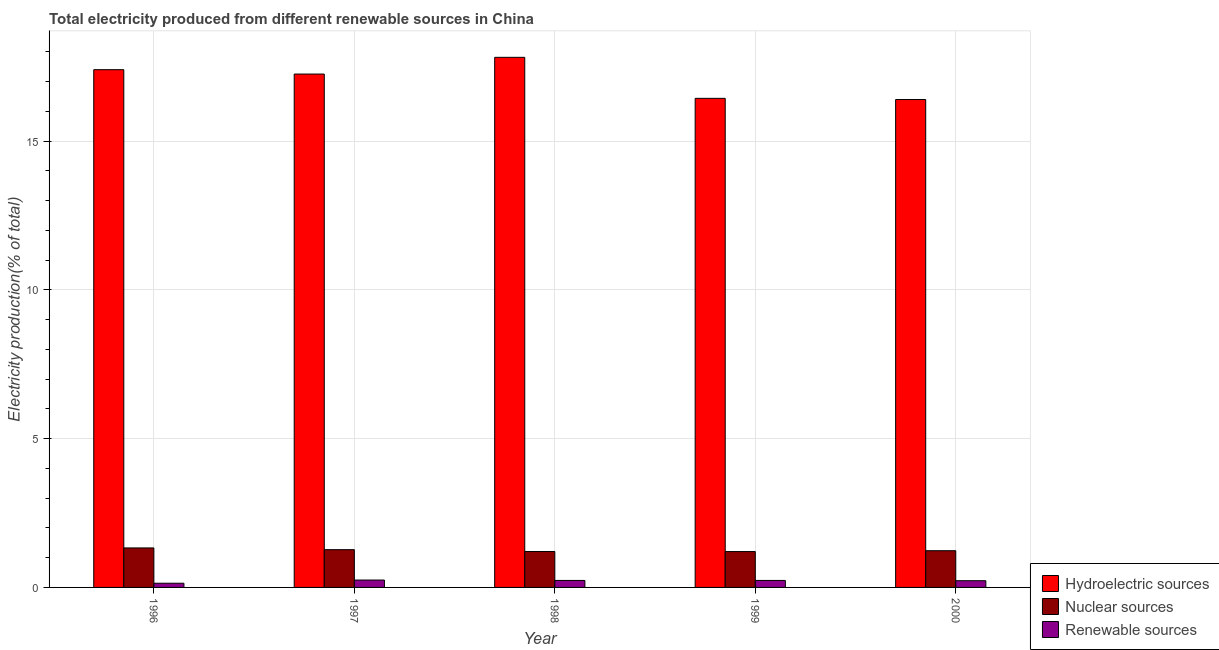How many different coloured bars are there?
Keep it short and to the point. 3. How many groups of bars are there?
Give a very brief answer. 5. How many bars are there on the 2nd tick from the right?
Provide a short and direct response. 3. What is the label of the 5th group of bars from the left?
Your response must be concise. 2000. What is the percentage of electricity produced by nuclear sources in 2000?
Give a very brief answer. 1.23. Across all years, what is the maximum percentage of electricity produced by nuclear sources?
Provide a succinct answer. 1.33. Across all years, what is the minimum percentage of electricity produced by nuclear sources?
Your response must be concise. 1.21. In which year was the percentage of electricity produced by renewable sources maximum?
Provide a succinct answer. 1997. What is the total percentage of electricity produced by renewable sources in the graph?
Your answer should be compact. 1.09. What is the difference between the percentage of electricity produced by hydroelectric sources in 1996 and that in 2000?
Provide a short and direct response. 1. What is the difference between the percentage of electricity produced by nuclear sources in 1999 and the percentage of electricity produced by renewable sources in 1997?
Provide a short and direct response. -0.06. What is the average percentage of electricity produced by hydroelectric sources per year?
Offer a very short reply. 17.06. In the year 1999, what is the difference between the percentage of electricity produced by nuclear sources and percentage of electricity produced by renewable sources?
Offer a terse response. 0. In how many years, is the percentage of electricity produced by nuclear sources greater than 15 %?
Make the answer very short. 0. What is the ratio of the percentage of electricity produced by renewable sources in 1996 to that in 2000?
Provide a short and direct response. 0.63. What is the difference between the highest and the second highest percentage of electricity produced by hydroelectric sources?
Provide a short and direct response. 0.42. What is the difference between the highest and the lowest percentage of electricity produced by renewable sources?
Give a very brief answer. 0.11. Is the sum of the percentage of electricity produced by nuclear sources in 1997 and 2000 greater than the maximum percentage of electricity produced by renewable sources across all years?
Make the answer very short. Yes. What does the 3rd bar from the left in 1996 represents?
Provide a succinct answer. Renewable sources. What does the 2nd bar from the right in 1999 represents?
Make the answer very short. Nuclear sources. Are all the bars in the graph horizontal?
Give a very brief answer. No. How many years are there in the graph?
Your answer should be compact. 5. What is the difference between two consecutive major ticks on the Y-axis?
Offer a very short reply. 5. How many legend labels are there?
Ensure brevity in your answer.  3. How are the legend labels stacked?
Offer a terse response. Vertical. What is the title of the graph?
Your response must be concise. Total electricity produced from different renewable sources in China. What is the Electricity production(% of total) of Hydroelectric sources in 1996?
Make the answer very short. 17.4. What is the Electricity production(% of total) of Nuclear sources in 1996?
Provide a short and direct response. 1.33. What is the Electricity production(% of total) of Renewable sources in 1996?
Provide a succinct answer. 0.14. What is the Electricity production(% of total) in Hydroelectric sources in 1997?
Make the answer very short. 17.26. What is the Electricity production(% of total) of Nuclear sources in 1997?
Offer a very short reply. 1.27. What is the Electricity production(% of total) in Renewable sources in 1997?
Your response must be concise. 0.25. What is the Electricity production(% of total) of Hydroelectric sources in 1998?
Your answer should be very brief. 17.82. What is the Electricity production(% of total) of Nuclear sources in 1998?
Make the answer very short. 1.21. What is the Electricity production(% of total) in Renewable sources in 1998?
Offer a terse response. 0.24. What is the Electricity production(% of total) of Hydroelectric sources in 1999?
Give a very brief answer. 16.44. What is the Electricity production(% of total) of Nuclear sources in 1999?
Make the answer very short. 1.21. What is the Electricity production(% of total) of Renewable sources in 1999?
Your answer should be very brief. 0.24. What is the Electricity production(% of total) in Hydroelectric sources in 2000?
Your response must be concise. 16.4. What is the Electricity production(% of total) in Nuclear sources in 2000?
Offer a terse response. 1.23. What is the Electricity production(% of total) in Renewable sources in 2000?
Your answer should be very brief. 0.23. Across all years, what is the maximum Electricity production(% of total) of Hydroelectric sources?
Provide a short and direct response. 17.82. Across all years, what is the maximum Electricity production(% of total) in Nuclear sources?
Provide a short and direct response. 1.33. Across all years, what is the maximum Electricity production(% of total) of Renewable sources?
Keep it short and to the point. 0.25. Across all years, what is the minimum Electricity production(% of total) of Hydroelectric sources?
Ensure brevity in your answer.  16.4. Across all years, what is the minimum Electricity production(% of total) in Nuclear sources?
Provide a short and direct response. 1.21. Across all years, what is the minimum Electricity production(% of total) in Renewable sources?
Your response must be concise. 0.14. What is the total Electricity production(% of total) in Hydroelectric sources in the graph?
Keep it short and to the point. 85.31. What is the total Electricity production(% of total) in Nuclear sources in the graph?
Provide a short and direct response. 6.24. What is the total Electricity production(% of total) in Renewable sources in the graph?
Your response must be concise. 1.09. What is the difference between the Electricity production(% of total) of Hydroelectric sources in 1996 and that in 1997?
Give a very brief answer. 0.15. What is the difference between the Electricity production(% of total) of Nuclear sources in 1996 and that in 1997?
Offer a very short reply. 0.06. What is the difference between the Electricity production(% of total) of Renewable sources in 1996 and that in 1997?
Provide a succinct answer. -0.11. What is the difference between the Electricity production(% of total) of Hydroelectric sources in 1996 and that in 1998?
Keep it short and to the point. -0.42. What is the difference between the Electricity production(% of total) of Nuclear sources in 1996 and that in 1998?
Provide a short and direct response. 0.12. What is the difference between the Electricity production(% of total) of Renewable sources in 1996 and that in 1998?
Give a very brief answer. -0.09. What is the difference between the Electricity production(% of total) of Hydroelectric sources in 1996 and that in 1999?
Offer a terse response. 0.96. What is the difference between the Electricity production(% of total) of Nuclear sources in 1996 and that in 1999?
Your answer should be compact. 0.12. What is the difference between the Electricity production(% of total) in Renewable sources in 1996 and that in 1999?
Give a very brief answer. -0.09. What is the difference between the Electricity production(% of total) of Hydroelectric sources in 1996 and that in 2000?
Your response must be concise. 1. What is the difference between the Electricity production(% of total) of Nuclear sources in 1996 and that in 2000?
Give a very brief answer. 0.09. What is the difference between the Electricity production(% of total) of Renewable sources in 1996 and that in 2000?
Your answer should be very brief. -0.08. What is the difference between the Electricity production(% of total) of Hydroelectric sources in 1997 and that in 1998?
Your answer should be compact. -0.56. What is the difference between the Electricity production(% of total) in Nuclear sources in 1997 and that in 1998?
Offer a very short reply. 0.06. What is the difference between the Electricity production(% of total) in Renewable sources in 1997 and that in 1998?
Offer a very short reply. 0.01. What is the difference between the Electricity production(% of total) in Hydroelectric sources in 1997 and that in 1999?
Make the answer very short. 0.82. What is the difference between the Electricity production(% of total) of Nuclear sources in 1997 and that in 1999?
Give a very brief answer. 0.06. What is the difference between the Electricity production(% of total) in Renewable sources in 1997 and that in 1999?
Give a very brief answer. 0.01. What is the difference between the Electricity production(% of total) in Hydroelectric sources in 1997 and that in 2000?
Keep it short and to the point. 0.86. What is the difference between the Electricity production(% of total) in Nuclear sources in 1997 and that in 2000?
Keep it short and to the point. 0.04. What is the difference between the Electricity production(% of total) of Renewable sources in 1997 and that in 2000?
Make the answer very short. 0.02. What is the difference between the Electricity production(% of total) in Hydroelectric sources in 1998 and that in 1999?
Offer a very short reply. 1.38. What is the difference between the Electricity production(% of total) of Nuclear sources in 1998 and that in 1999?
Your answer should be compact. 0. What is the difference between the Electricity production(% of total) in Renewable sources in 1998 and that in 1999?
Make the answer very short. 0. What is the difference between the Electricity production(% of total) of Hydroelectric sources in 1998 and that in 2000?
Give a very brief answer. 1.42. What is the difference between the Electricity production(% of total) in Nuclear sources in 1998 and that in 2000?
Make the answer very short. -0.03. What is the difference between the Electricity production(% of total) of Renewable sources in 1998 and that in 2000?
Make the answer very short. 0.01. What is the difference between the Electricity production(% of total) of Hydroelectric sources in 1999 and that in 2000?
Provide a short and direct response. 0.04. What is the difference between the Electricity production(% of total) in Nuclear sources in 1999 and that in 2000?
Your response must be concise. -0.03. What is the difference between the Electricity production(% of total) in Renewable sources in 1999 and that in 2000?
Ensure brevity in your answer.  0.01. What is the difference between the Electricity production(% of total) in Hydroelectric sources in 1996 and the Electricity production(% of total) in Nuclear sources in 1997?
Your answer should be compact. 16.13. What is the difference between the Electricity production(% of total) of Hydroelectric sources in 1996 and the Electricity production(% of total) of Renewable sources in 1997?
Make the answer very short. 17.15. What is the difference between the Electricity production(% of total) of Nuclear sources in 1996 and the Electricity production(% of total) of Renewable sources in 1997?
Provide a short and direct response. 1.08. What is the difference between the Electricity production(% of total) in Hydroelectric sources in 1996 and the Electricity production(% of total) in Nuclear sources in 1998?
Provide a short and direct response. 16.19. What is the difference between the Electricity production(% of total) of Hydroelectric sources in 1996 and the Electricity production(% of total) of Renewable sources in 1998?
Keep it short and to the point. 17.17. What is the difference between the Electricity production(% of total) in Nuclear sources in 1996 and the Electricity production(% of total) in Renewable sources in 1998?
Offer a terse response. 1.09. What is the difference between the Electricity production(% of total) in Hydroelectric sources in 1996 and the Electricity production(% of total) in Nuclear sources in 1999?
Your answer should be compact. 16.2. What is the difference between the Electricity production(% of total) of Hydroelectric sources in 1996 and the Electricity production(% of total) of Renewable sources in 1999?
Ensure brevity in your answer.  17.17. What is the difference between the Electricity production(% of total) of Nuclear sources in 1996 and the Electricity production(% of total) of Renewable sources in 1999?
Your answer should be very brief. 1.09. What is the difference between the Electricity production(% of total) of Hydroelectric sources in 1996 and the Electricity production(% of total) of Nuclear sources in 2000?
Provide a short and direct response. 16.17. What is the difference between the Electricity production(% of total) in Hydroelectric sources in 1996 and the Electricity production(% of total) in Renewable sources in 2000?
Give a very brief answer. 17.18. What is the difference between the Electricity production(% of total) in Nuclear sources in 1996 and the Electricity production(% of total) in Renewable sources in 2000?
Give a very brief answer. 1.1. What is the difference between the Electricity production(% of total) of Hydroelectric sources in 1997 and the Electricity production(% of total) of Nuclear sources in 1998?
Offer a terse response. 16.05. What is the difference between the Electricity production(% of total) of Hydroelectric sources in 1997 and the Electricity production(% of total) of Renewable sources in 1998?
Provide a succinct answer. 17.02. What is the difference between the Electricity production(% of total) in Nuclear sources in 1997 and the Electricity production(% of total) in Renewable sources in 1998?
Ensure brevity in your answer.  1.03. What is the difference between the Electricity production(% of total) of Hydroelectric sources in 1997 and the Electricity production(% of total) of Nuclear sources in 1999?
Offer a very short reply. 16.05. What is the difference between the Electricity production(% of total) in Hydroelectric sources in 1997 and the Electricity production(% of total) in Renewable sources in 1999?
Offer a very short reply. 17.02. What is the difference between the Electricity production(% of total) in Nuclear sources in 1997 and the Electricity production(% of total) in Renewable sources in 1999?
Ensure brevity in your answer.  1.03. What is the difference between the Electricity production(% of total) of Hydroelectric sources in 1997 and the Electricity production(% of total) of Nuclear sources in 2000?
Provide a short and direct response. 16.02. What is the difference between the Electricity production(% of total) of Hydroelectric sources in 1997 and the Electricity production(% of total) of Renewable sources in 2000?
Provide a succinct answer. 17.03. What is the difference between the Electricity production(% of total) of Nuclear sources in 1997 and the Electricity production(% of total) of Renewable sources in 2000?
Give a very brief answer. 1.04. What is the difference between the Electricity production(% of total) of Hydroelectric sources in 1998 and the Electricity production(% of total) of Nuclear sources in 1999?
Provide a succinct answer. 16.61. What is the difference between the Electricity production(% of total) in Hydroelectric sources in 1998 and the Electricity production(% of total) in Renewable sources in 1999?
Offer a very short reply. 17.58. What is the difference between the Electricity production(% of total) in Nuclear sources in 1998 and the Electricity production(% of total) in Renewable sources in 1999?
Your answer should be compact. 0.97. What is the difference between the Electricity production(% of total) in Hydroelectric sources in 1998 and the Electricity production(% of total) in Nuclear sources in 2000?
Make the answer very short. 16.58. What is the difference between the Electricity production(% of total) of Hydroelectric sources in 1998 and the Electricity production(% of total) of Renewable sources in 2000?
Make the answer very short. 17.59. What is the difference between the Electricity production(% of total) in Nuclear sources in 1998 and the Electricity production(% of total) in Renewable sources in 2000?
Your response must be concise. 0.98. What is the difference between the Electricity production(% of total) in Hydroelectric sources in 1999 and the Electricity production(% of total) in Nuclear sources in 2000?
Ensure brevity in your answer.  15.2. What is the difference between the Electricity production(% of total) of Hydroelectric sources in 1999 and the Electricity production(% of total) of Renewable sources in 2000?
Offer a terse response. 16.21. What is the difference between the Electricity production(% of total) of Nuclear sources in 1999 and the Electricity production(% of total) of Renewable sources in 2000?
Your response must be concise. 0.98. What is the average Electricity production(% of total) in Hydroelectric sources per year?
Provide a succinct answer. 17.06. What is the average Electricity production(% of total) in Nuclear sources per year?
Make the answer very short. 1.25. What is the average Electricity production(% of total) in Renewable sources per year?
Give a very brief answer. 0.22. In the year 1996, what is the difference between the Electricity production(% of total) of Hydroelectric sources and Electricity production(% of total) of Nuclear sources?
Offer a very short reply. 16.07. In the year 1996, what is the difference between the Electricity production(% of total) in Hydroelectric sources and Electricity production(% of total) in Renewable sources?
Provide a short and direct response. 17.26. In the year 1996, what is the difference between the Electricity production(% of total) in Nuclear sources and Electricity production(% of total) in Renewable sources?
Keep it short and to the point. 1.19. In the year 1997, what is the difference between the Electricity production(% of total) of Hydroelectric sources and Electricity production(% of total) of Nuclear sources?
Keep it short and to the point. 15.99. In the year 1997, what is the difference between the Electricity production(% of total) of Hydroelectric sources and Electricity production(% of total) of Renewable sources?
Your answer should be very brief. 17.01. In the year 1997, what is the difference between the Electricity production(% of total) in Nuclear sources and Electricity production(% of total) in Renewable sources?
Your answer should be very brief. 1.02. In the year 1998, what is the difference between the Electricity production(% of total) in Hydroelectric sources and Electricity production(% of total) in Nuclear sources?
Provide a short and direct response. 16.61. In the year 1998, what is the difference between the Electricity production(% of total) of Hydroelectric sources and Electricity production(% of total) of Renewable sources?
Keep it short and to the point. 17.58. In the year 1998, what is the difference between the Electricity production(% of total) of Nuclear sources and Electricity production(% of total) of Renewable sources?
Provide a short and direct response. 0.97. In the year 1999, what is the difference between the Electricity production(% of total) in Hydroelectric sources and Electricity production(% of total) in Nuclear sources?
Make the answer very short. 15.23. In the year 1999, what is the difference between the Electricity production(% of total) of Hydroelectric sources and Electricity production(% of total) of Renewable sources?
Offer a very short reply. 16.2. In the year 1999, what is the difference between the Electricity production(% of total) of Nuclear sources and Electricity production(% of total) of Renewable sources?
Offer a terse response. 0.97. In the year 2000, what is the difference between the Electricity production(% of total) of Hydroelectric sources and Electricity production(% of total) of Nuclear sources?
Your answer should be compact. 15.17. In the year 2000, what is the difference between the Electricity production(% of total) of Hydroelectric sources and Electricity production(% of total) of Renewable sources?
Keep it short and to the point. 16.17. In the year 2000, what is the difference between the Electricity production(% of total) of Nuclear sources and Electricity production(% of total) of Renewable sources?
Your answer should be compact. 1.01. What is the ratio of the Electricity production(% of total) in Hydroelectric sources in 1996 to that in 1997?
Your answer should be compact. 1.01. What is the ratio of the Electricity production(% of total) of Nuclear sources in 1996 to that in 1997?
Provide a short and direct response. 1.05. What is the ratio of the Electricity production(% of total) in Renewable sources in 1996 to that in 1997?
Keep it short and to the point. 0.57. What is the ratio of the Electricity production(% of total) of Hydroelectric sources in 1996 to that in 1998?
Give a very brief answer. 0.98. What is the ratio of the Electricity production(% of total) of Nuclear sources in 1996 to that in 1998?
Your answer should be compact. 1.1. What is the ratio of the Electricity production(% of total) in Renewable sources in 1996 to that in 1998?
Provide a succinct answer. 0.6. What is the ratio of the Electricity production(% of total) of Hydroelectric sources in 1996 to that in 1999?
Your response must be concise. 1.06. What is the ratio of the Electricity production(% of total) of Nuclear sources in 1996 to that in 1999?
Ensure brevity in your answer.  1.1. What is the ratio of the Electricity production(% of total) in Renewable sources in 1996 to that in 1999?
Your response must be concise. 0.6. What is the ratio of the Electricity production(% of total) in Hydroelectric sources in 1996 to that in 2000?
Your answer should be very brief. 1.06. What is the ratio of the Electricity production(% of total) in Nuclear sources in 1996 to that in 2000?
Offer a terse response. 1.08. What is the ratio of the Electricity production(% of total) of Renewable sources in 1996 to that in 2000?
Your answer should be compact. 0.63. What is the ratio of the Electricity production(% of total) of Hydroelectric sources in 1997 to that in 1998?
Keep it short and to the point. 0.97. What is the ratio of the Electricity production(% of total) of Nuclear sources in 1997 to that in 1998?
Make the answer very short. 1.05. What is the ratio of the Electricity production(% of total) of Renewable sources in 1997 to that in 1998?
Provide a short and direct response. 1.06. What is the ratio of the Electricity production(% of total) in Hydroelectric sources in 1997 to that in 1999?
Provide a succinct answer. 1.05. What is the ratio of the Electricity production(% of total) of Nuclear sources in 1997 to that in 1999?
Offer a terse response. 1.05. What is the ratio of the Electricity production(% of total) of Renewable sources in 1997 to that in 1999?
Your answer should be very brief. 1.06. What is the ratio of the Electricity production(% of total) in Hydroelectric sources in 1997 to that in 2000?
Your answer should be very brief. 1.05. What is the ratio of the Electricity production(% of total) of Nuclear sources in 1997 to that in 2000?
Your answer should be compact. 1.03. What is the ratio of the Electricity production(% of total) of Renewable sources in 1997 to that in 2000?
Offer a terse response. 1.1. What is the ratio of the Electricity production(% of total) of Hydroelectric sources in 1998 to that in 1999?
Offer a terse response. 1.08. What is the ratio of the Electricity production(% of total) in Hydroelectric sources in 1998 to that in 2000?
Provide a short and direct response. 1.09. What is the ratio of the Electricity production(% of total) of Nuclear sources in 1998 to that in 2000?
Your response must be concise. 0.98. What is the ratio of the Electricity production(% of total) in Renewable sources in 1998 to that in 2000?
Provide a succinct answer. 1.04. What is the ratio of the Electricity production(% of total) of Hydroelectric sources in 1999 to that in 2000?
Provide a succinct answer. 1. What is the ratio of the Electricity production(% of total) of Nuclear sources in 1999 to that in 2000?
Offer a terse response. 0.98. What is the ratio of the Electricity production(% of total) of Renewable sources in 1999 to that in 2000?
Give a very brief answer. 1.04. What is the difference between the highest and the second highest Electricity production(% of total) in Hydroelectric sources?
Ensure brevity in your answer.  0.42. What is the difference between the highest and the second highest Electricity production(% of total) in Nuclear sources?
Your answer should be very brief. 0.06. What is the difference between the highest and the second highest Electricity production(% of total) in Renewable sources?
Ensure brevity in your answer.  0.01. What is the difference between the highest and the lowest Electricity production(% of total) of Hydroelectric sources?
Keep it short and to the point. 1.42. What is the difference between the highest and the lowest Electricity production(% of total) in Nuclear sources?
Provide a succinct answer. 0.12. What is the difference between the highest and the lowest Electricity production(% of total) of Renewable sources?
Offer a very short reply. 0.11. 